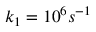<formula> <loc_0><loc_0><loc_500><loc_500>k _ { 1 } = 1 0 ^ { 6 } s ^ { - 1 }</formula> 